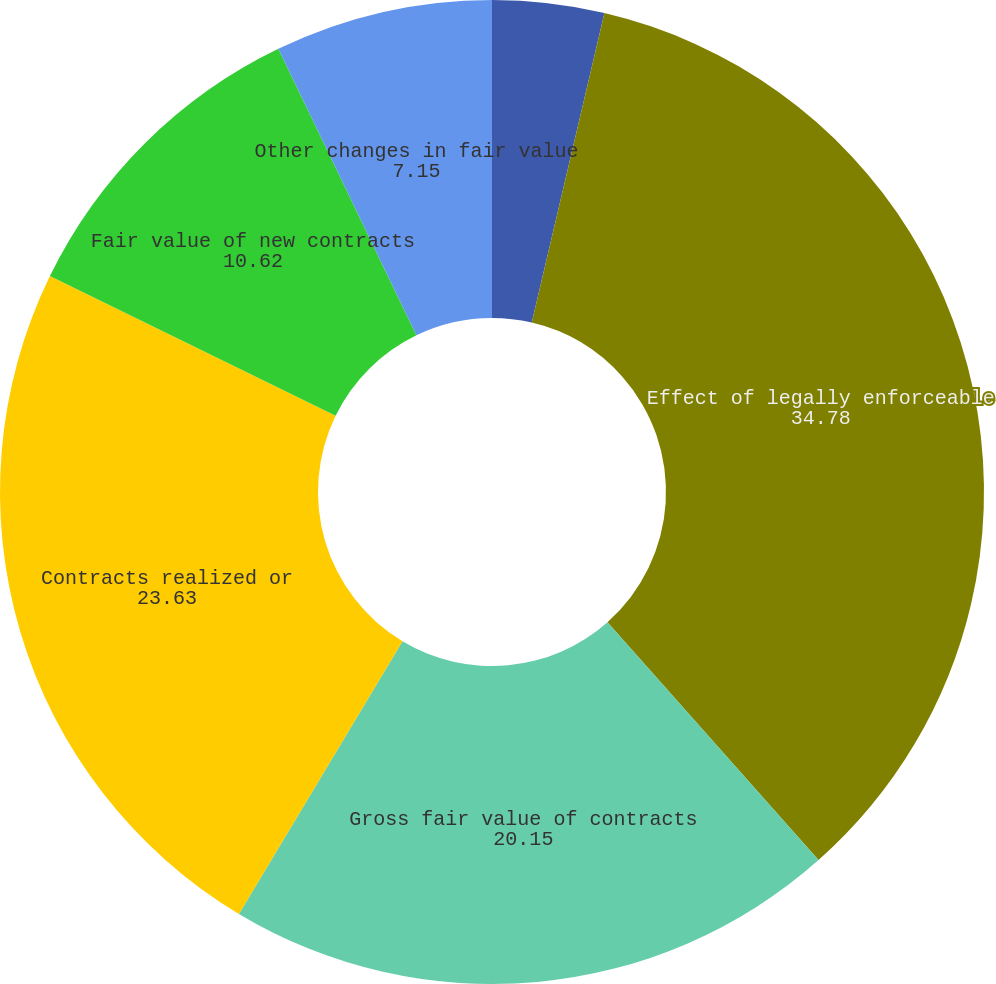Convert chart. <chart><loc_0><loc_0><loc_500><loc_500><pie_chart><fcel>Net fair value of contracts<fcel>Effect of legally enforceable<fcel>Gross fair value of contracts<fcel>Contracts realized or<fcel>Fair value of new contracts<fcel>Other changes in fair value<nl><fcel>3.67%<fcel>34.78%<fcel>20.15%<fcel>23.63%<fcel>10.62%<fcel>7.15%<nl></chart> 